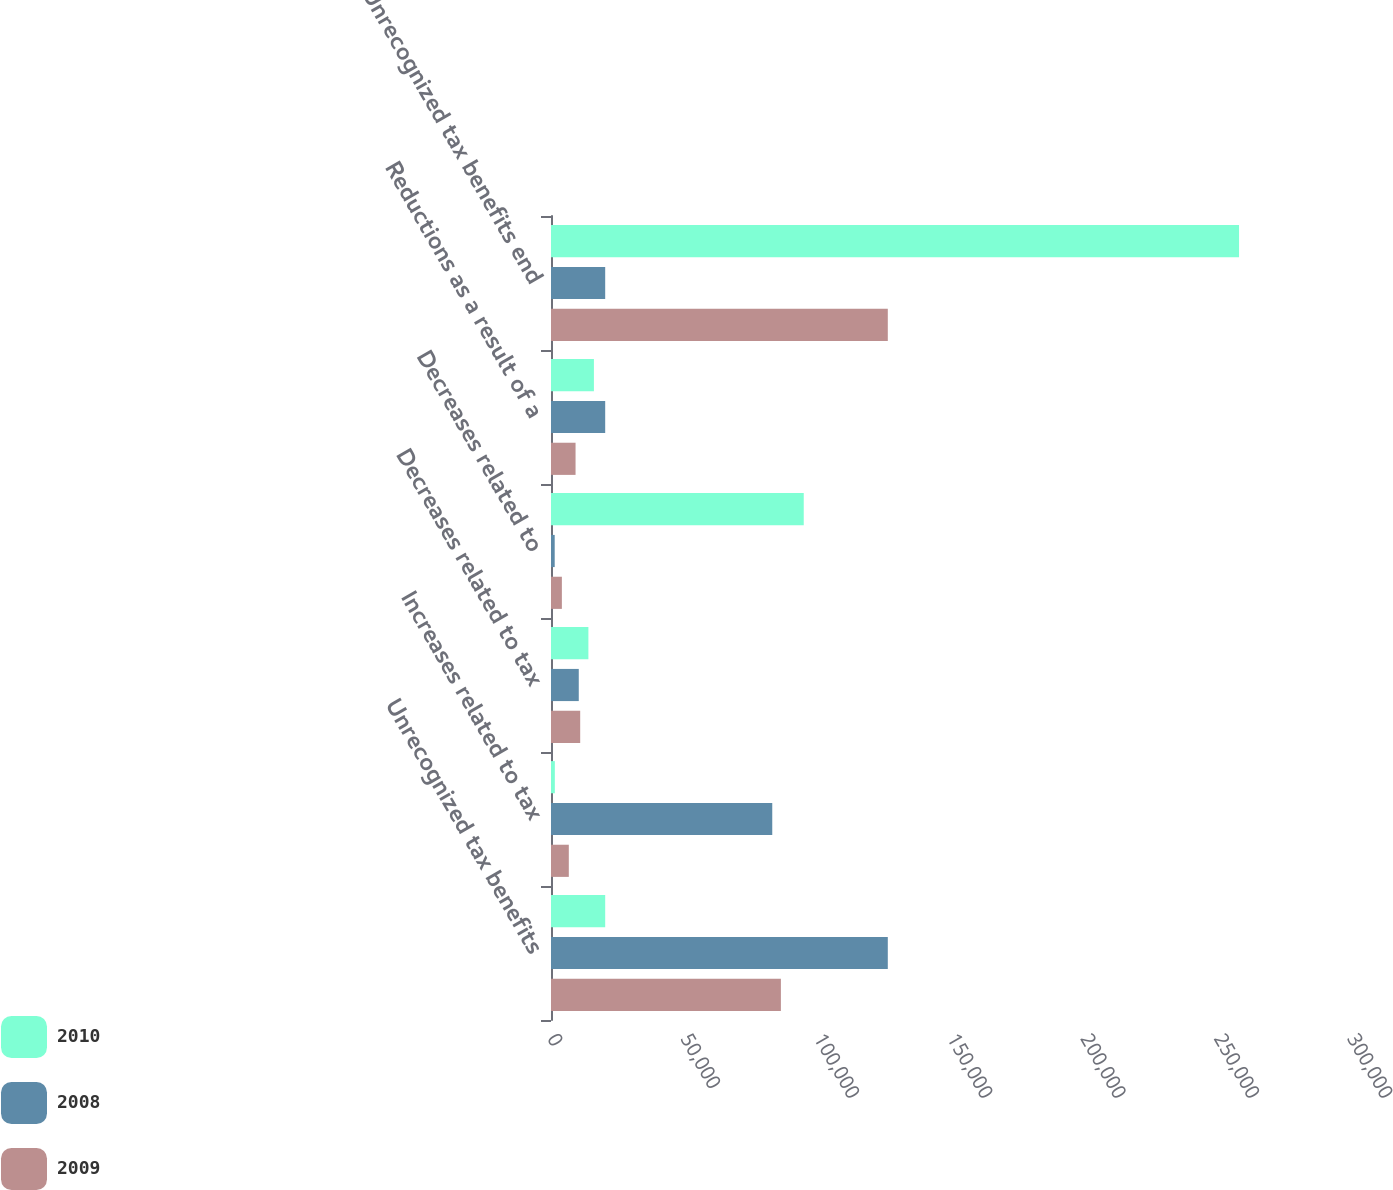Convert chart. <chart><loc_0><loc_0><loc_500><loc_500><stacked_bar_chart><ecel><fcel>Unrecognized tax benefits<fcel>Increases related to tax<fcel>Decreases related to tax<fcel>Decreases related to<fcel>Reductions as a result of a<fcel>Unrecognized tax benefits end<nl><fcel>2010<fcel>20322<fcel>1441<fcel>14025<fcel>94779<fcel>16094<fcel>258016<nl><fcel>2008<fcel>126299<fcel>82973<fcel>10414<fcel>1389<fcel>20322<fcel>20322<nl><fcel>2009<fcel>86209<fcel>6678<fcel>10951<fcel>4078<fcel>9206<fcel>126299<nl></chart> 